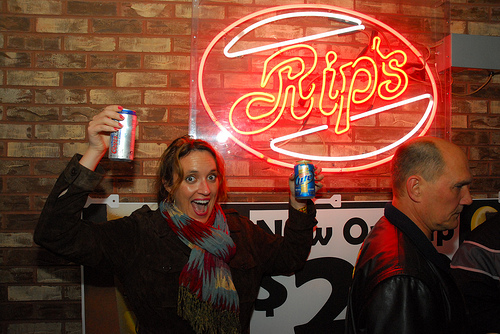<image>
Can you confirm if the beer is behind the sign? No. The beer is not behind the sign. From this viewpoint, the beer appears to be positioned elsewhere in the scene. Is the beer under the sign? Yes. The beer is positioned underneath the sign, with the sign above it in the vertical space. 